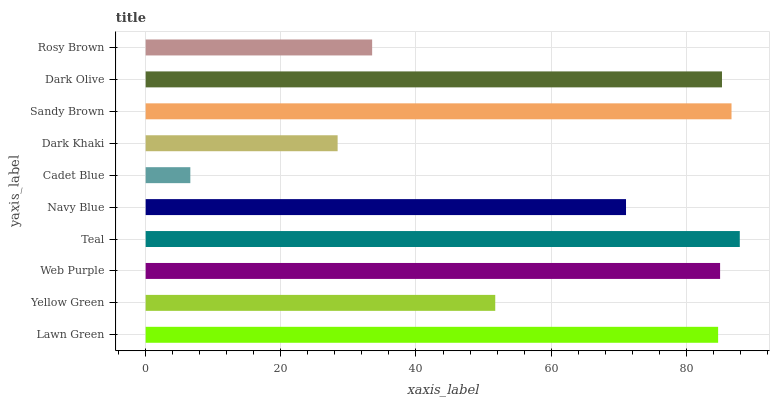Is Cadet Blue the minimum?
Answer yes or no. Yes. Is Teal the maximum?
Answer yes or no. Yes. Is Yellow Green the minimum?
Answer yes or no. No. Is Yellow Green the maximum?
Answer yes or no. No. Is Lawn Green greater than Yellow Green?
Answer yes or no. Yes. Is Yellow Green less than Lawn Green?
Answer yes or no. Yes. Is Yellow Green greater than Lawn Green?
Answer yes or no. No. Is Lawn Green less than Yellow Green?
Answer yes or no. No. Is Lawn Green the high median?
Answer yes or no. Yes. Is Navy Blue the low median?
Answer yes or no. Yes. Is Dark Olive the high median?
Answer yes or no. No. Is Sandy Brown the low median?
Answer yes or no. No. 